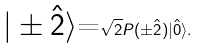<formula> <loc_0><loc_0><loc_500><loc_500>\text {$| \pm \hat{2} \rangle$=} \sqrt { 2 } P ( \pm \hat { 2 } ) | \hat { 0 } \rangle .</formula> 